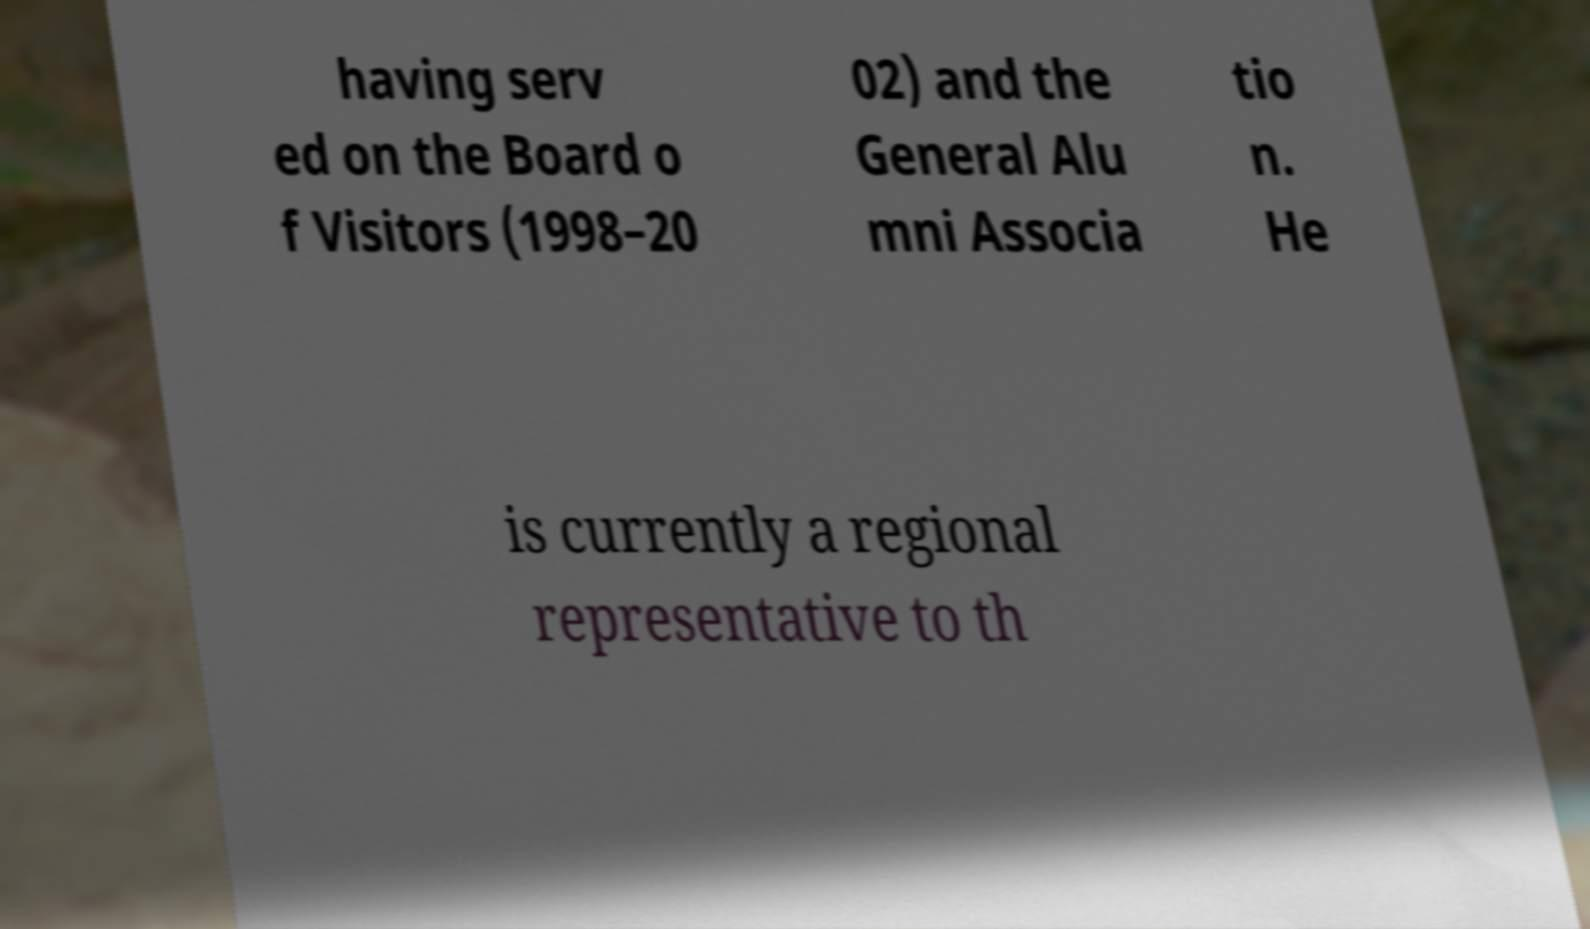For documentation purposes, I need the text within this image transcribed. Could you provide that? having serv ed on the Board o f Visitors (1998–20 02) and the General Alu mni Associa tio n. He is currently a regional representative to th 